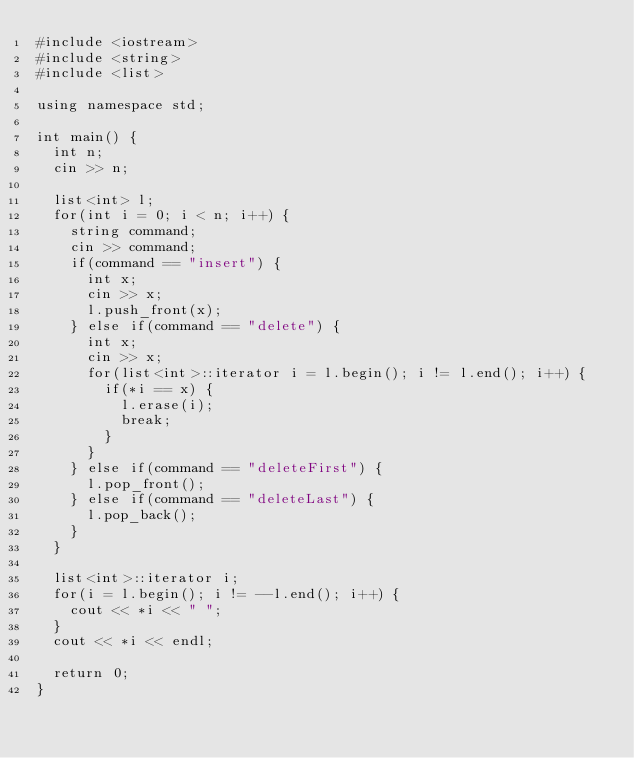<code> <loc_0><loc_0><loc_500><loc_500><_C++_>#include <iostream>
#include <string>
#include <list>

using namespace std;

int main() {
  int n;
  cin >> n;

  list<int> l;
  for(int i = 0; i < n; i++) {
    string command;
    cin >> command;
    if(command == "insert") {
      int x;
      cin >> x;
      l.push_front(x);
    } else if(command == "delete") {
      int x;
      cin >> x;
      for(list<int>::iterator i = l.begin(); i != l.end(); i++) {
        if(*i == x) {
          l.erase(i);
          break;
        }
      }
    } else if(command == "deleteFirst") {
      l.pop_front();
    } else if(command == "deleteLast") {
      l.pop_back();
    }
  }

  list<int>::iterator i;
  for(i = l.begin(); i != --l.end(); i++) {
    cout << *i << " ";
  }
  cout << *i << endl;

  return 0;
}
</code> 